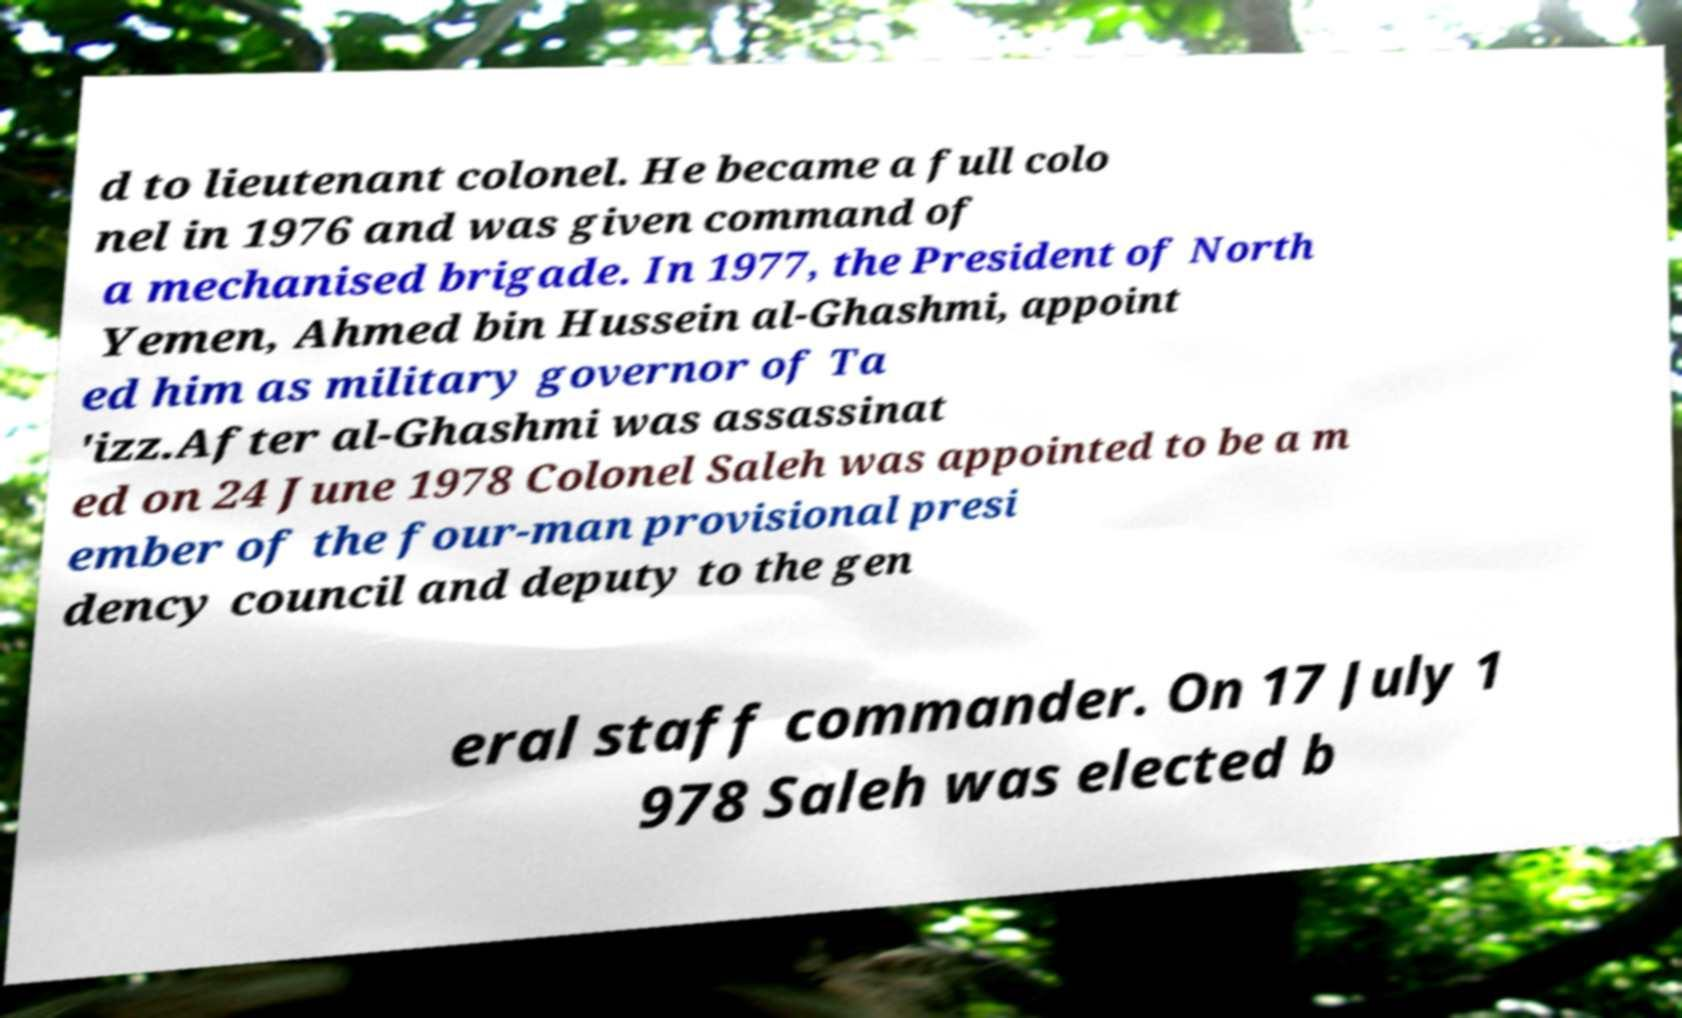I need the written content from this picture converted into text. Can you do that? d to lieutenant colonel. He became a full colo nel in 1976 and was given command of a mechanised brigade. In 1977, the President of North Yemen, Ahmed bin Hussein al-Ghashmi, appoint ed him as military governor of Ta 'izz.After al-Ghashmi was assassinat ed on 24 June 1978 Colonel Saleh was appointed to be a m ember of the four-man provisional presi dency council and deputy to the gen eral staff commander. On 17 July 1 978 Saleh was elected b 